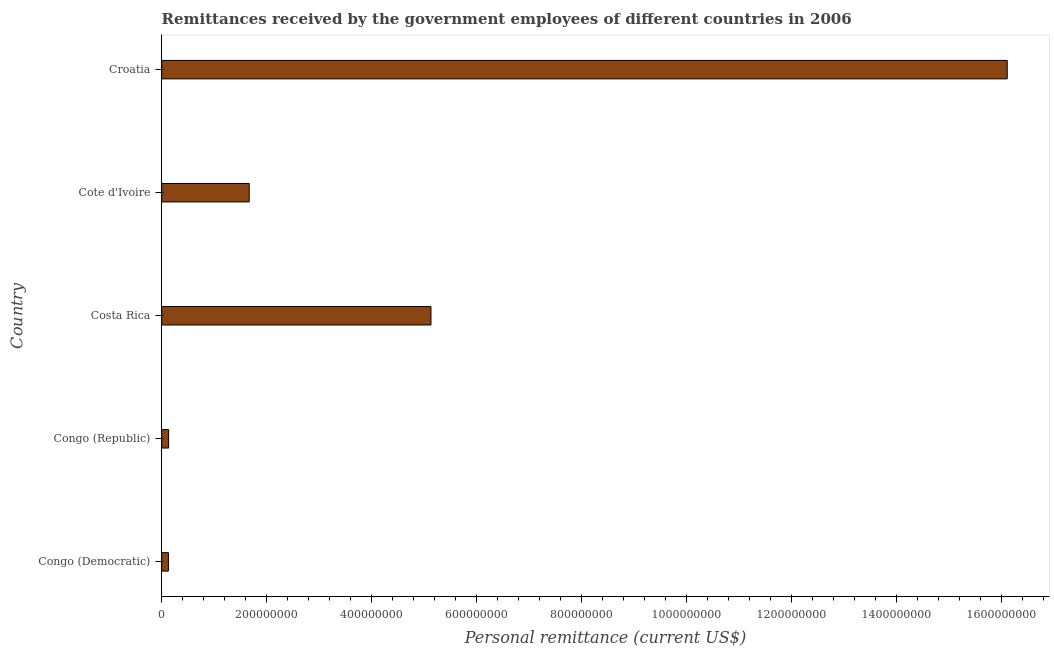What is the title of the graph?
Provide a short and direct response. Remittances received by the government employees of different countries in 2006. What is the label or title of the X-axis?
Provide a short and direct response. Personal remittance (current US$). What is the personal remittances in Congo (Republic)?
Give a very brief answer. 1.32e+07. Across all countries, what is the maximum personal remittances?
Your answer should be compact. 1.61e+09. Across all countries, what is the minimum personal remittances?
Ensure brevity in your answer.  1.28e+07. In which country was the personal remittances maximum?
Offer a terse response. Croatia. In which country was the personal remittances minimum?
Ensure brevity in your answer.  Congo (Democratic). What is the sum of the personal remittances?
Give a very brief answer. 2.32e+09. What is the difference between the personal remittances in Costa Rica and Cote d'Ivoire?
Give a very brief answer. 3.46e+08. What is the average personal remittances per country?
Your answer should be compact. 4.63e+08. What is the median personal remittances?
Keep it short and to the point. 1.67e+08. What is the ratio of the personal remittances in Congo (Democratic) to that in Cote d'Ivoire?
Offer a very short reply. 0.08. What is the difference between the highest and the second highest personal remittances?
Make the answer very short. 1.10e+09. What is the difference between the highest and the lowest personal remittances?
Your response must be concise. 1.60e+09. In how many countries, is the personal remittances greater than the average personal remittances taken over all countries?
Your answer should be compact. 2. How many bars are there?
Provide a succinct answer. 5. Are all the bars in the graph horizontal?
Provide a short and direct response. Yes. Are the values on the major ticks of X-axis written in scientific E-notation?
Your answer should be compact. No. What is the Personal remittance (current US$) in Congo (Democratic)?
Offer a very short reply. 1.28e+07. What is the Personal remittance (current US$) in Congo (Republic)?
Provide a short and direct response. 1.32e+07. What is the Personal remittance (current US$) of Costa Rica?
Ensure brevity in your answer.  5.13e+08. What is the Personal remittance (current US$) of Cote d'Ivoire?
Your answer should be compact. 1.67e+08. What is the Personal remittance (current US$) of Croatia?
Your response must be concise. 1.61e+09. What is the difference between the Personal remittance (current US$) in Congo (Democratic) and Congo (Republic)?
Give a very brief answer. -3.96e+05. What is the difference between the Personal remittance (current US$) in Congo (Democratic) and Costa Rica?
Your answer should be compact. -5.00e+08. What is the difference between the Personal remittance (current US$) in Congo (Democratic) and Cote d'Ivoire?
Your response must be concise. -1.54e+08. What is the difference between the Personal remittance (current US$) in Congo (Democratic) and Croatia?
Keep it short and to the point. -1.60e+09. What is the difference between the Personal remittance (current US$) in Congo (Republic) and Costa Rica?
Offer a very short reply. -5.00e+08. What is the difference between the Personal remittance (current US$) in Congo (Republic) and Cote d'Ivoire?
Your answer should be very brief. -1.54e+08. What is the difference between the Personal remittance (current US$) in Congo (Republic) and Croatia?
Provide a succinct answer. -1.60e+09. What is the difference between the Personal remittance (current US$) in Costa Rica and Cote d'Ivoire?
Your answer should be compact. 3.46e+08. What is the difference between the Personal remittance (current US$) in Costa Rica and Croatia?
Provide a short and direct response. -1.10e+09. What is the difference between the Personal remittance (current US$) in Cote d'Ivoire and Croatia?
Provide a short and direct response. -1.44e+09. What is the ratio of the Personal remittance (current US$) in Congo (Democratic) to that in Costa Rica?
Offer a very short reply. 0.03. What is the ratio of the Personal remittance (current US$) in Congo (Democratic) to that in Cote d'Ivoire?
Offer a very short reply. 0.08. What is the ratio of the Personal remittance (current US$) in Congo (Democratic) to that in Croatia?
Ensure brevity in your answer.  0.01. What is the ratio of the Personal remittance (current US$) in Congo (Republic) to that in Costa Rica?
Give a very brief answer. 0.03. What is the ratio of the Personal remittance (current US$) in Congo (Republic) to that in Cote d'Ivoire?
Keep it short and to the point. 0.08. What is the ratio of the Personal remittance (current US$) in Congo (Republic) to that in Croatia?
Your response must be concise. 0.01. What is the ratio of the Personal remittance (current US$) in Costa Rica to that in Cote d'Ivoire?
Offer a terse response. 3.08. What is the ratio of the Personal remittance (current US$) in Costa Rica to that in Croatia?
Make the answer very short. 0.32. What is the ratio of the Personal remittance (current US$) in Cote d'Ivoire to that in Croatia?
Provide a short and direct response. 0.1. 